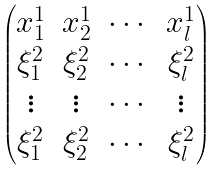<formula> <loc_0><loc_0><loc_500><loc_500>\begin{pmatrix} x _ { 1 } ^ { 1 } & x _ { 2 } ^ { 1 } & \cdots & x ^ { 1 } _ { l } \\ \xi _ { 1 } ^ { 2 } & \xi _ { 2 } ^ { 2 } & \cdots & \xi _ { l } ^ { 2 } \\ \vdots & \vdots & \cdots & \vdots \\ \xi _ { 1 } ^ { 2 } & \xi _ { 2 } ^ { 2 } & \cdots & \xi ^ { 2 } _ { l } \\ \end{pmatrix}</formula> 